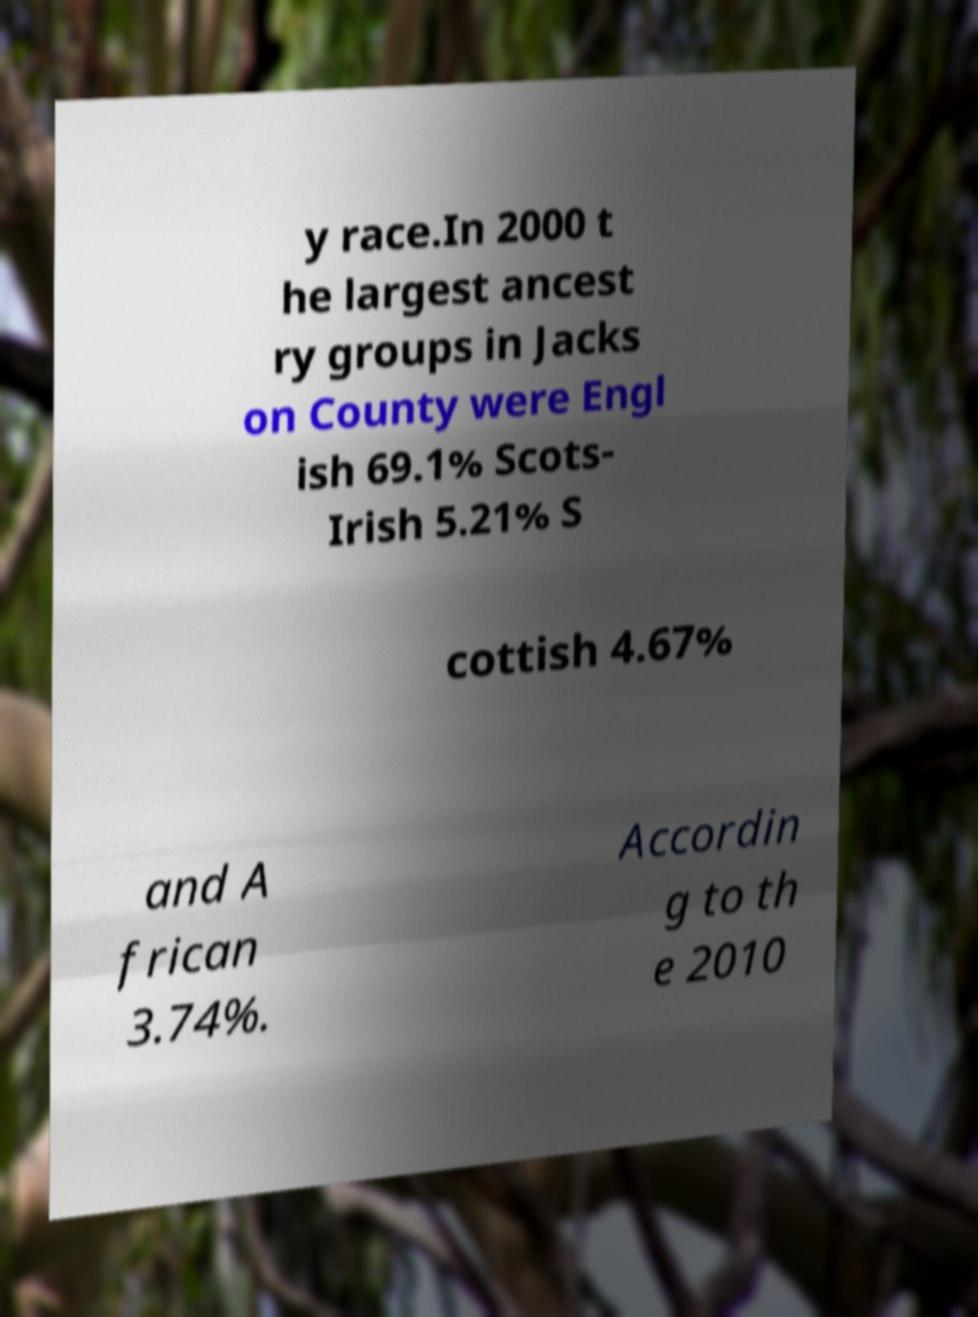Please identify and transcribe the text found in this image. y race.In 2000 t he largest ancest ry groups in Jacks on County were Engl ish 69.1% Scots- Irish 5.21% S cottish 4.67% and A frican 3.74%. Accordin g to th e 2010 